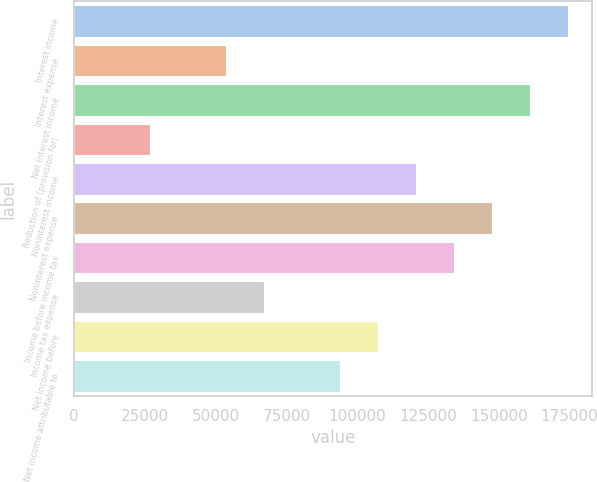Convert chart. <chart><loc_0><loc_0><loc_500><loc_500><bar_chart><fcel>Interest income<fcel>Interest expense<fcel>Net interest income<fcel>Reduction of (provision for)<fcel>Noninterest income<fcel>Noninterest expense<fcel>Income before income tax<fcel>Income tax expense<fcel>Net income before<fcel>Net income attributable to<nl><fcel>174331<fcel>53640.8<fcel>160921<fcel>26820.8<fcel>120691<fcel>147511<fcel>134101<fcel>67050.9<fcel>107281<fcel>93870.9<nl></chart> 